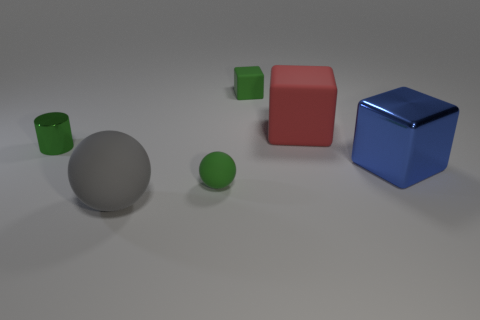Add 3 gray matte things. How many objects exist? 9 Subtract all balls. How many objects are left? 4 Subtract 1 blocks. How many blocks are left? 2 Subtract all green balls. How many balls are left? 1 Subtract all big blocks. How many blocks are left? 1 Subtract 1 gray spheres. How many objects are left? 5 Subtract all cyan blocks. Subtract all green cylinders. How many blocks are left? 3 Subtract all purple cylinders. How many green balls are left? 1 Subtract all red objects. Subtract all large purple metal cylinders. How many objects are left? 5 Add 2 small matte things. How many small matte things are left? 4 